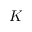Convert formula to latex. <formula><loc_0><loc_0><loc_500><loc_500>K</formula> 